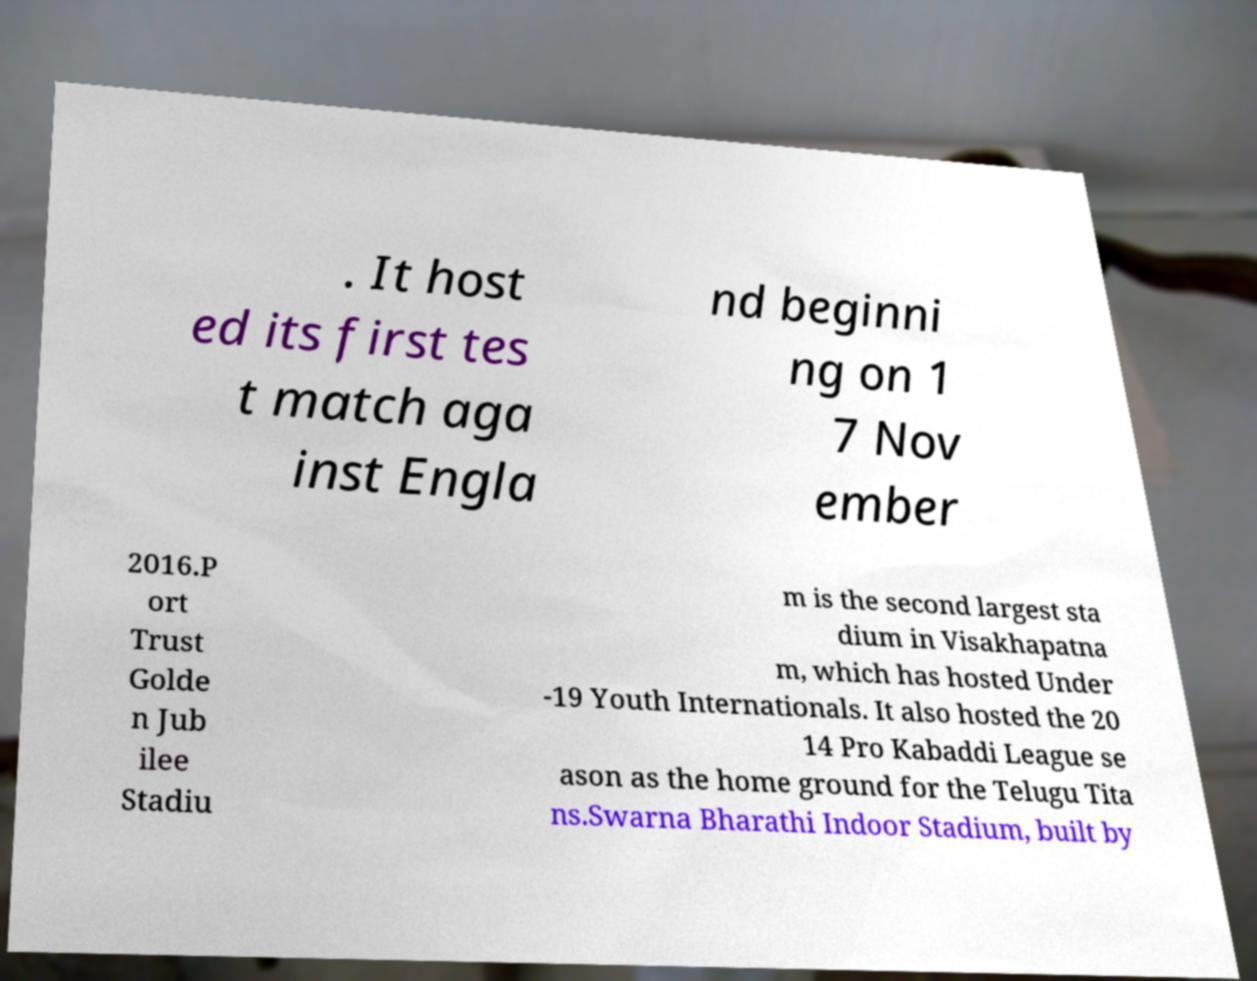Please read and relay the text visible in this image. What does it say? . It host ed its first tes t match aga inst Engla nd beginni ng on 1 7 Nov ember 2016.P ort Trust Golde n Jub ilee Stadiu m is the second largest sta dium in Visakhapatna m, which has hosted Under -19 Youth Internationals. It also hosted the 20 14 Pro Kabaddi League se ason as the home ground for the Telugu Tita ns.Swarna Bharathi Indoor Stadium, built by 